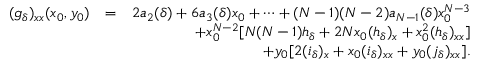<formula> <loc_0><loc_0><loc_500><loc_500>\begin{array} { r l r } { ( g _ { \delta } ) _ { x x } ( x _ { 0 } , y _ { 0 } ) } & { = } & { 2 a _ { 2 } ( \delta ) + 6 a _ { 3 } ( \delta ) x _ { 0 } + \cdots + ( N - 1 ) ( N - 2 ) a _ { N - 1 } ( \delta ) x _ { 0 } ^ { N - 3 } } \\ & { + x _ { 0 } ^ { N - 2 } [ N ( N - 1 ) h _ { \delta } + 2 N x _ { 0 } ( h _ { \delta } ) _ { x } + x _ { 0 } ^ { 2 } ( h _ { \delta } ) _ { x x } ] } \\ & { + y _ { 0 } [ 2 ( i _ { \delta } ) _ { x } + x _ { 0 } ( i _ { \delta } ) _ { x x } + y _ { 0 } ( j _ { \delta } ) _ { x x } ] . } \end{array}</formula> 